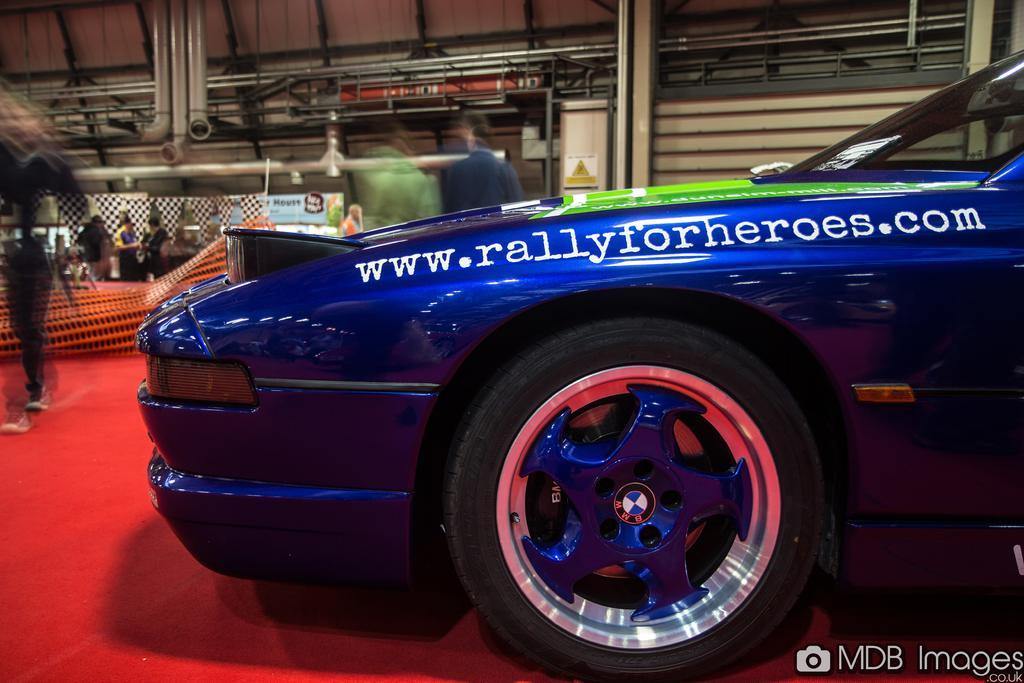Can you describe this image briefly? In this image, we can see a blue color vehicle is placed on the red carpet. Right side bottom corner, we can see a watermark in the image. Background we can see wall, pillars, pipes, banners, few people. 